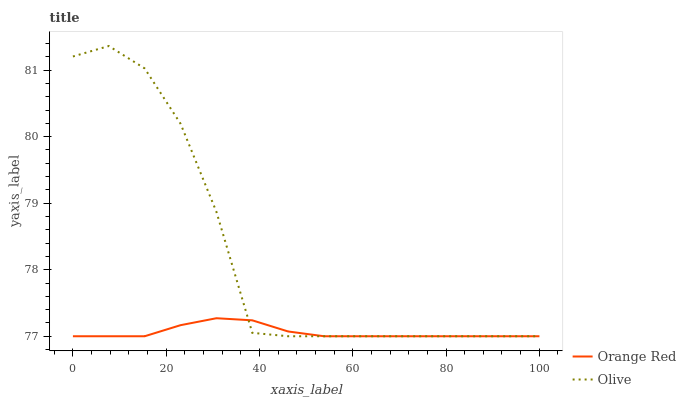Does Orange Red have the minimum area under the curve?
Answer yes or no. Yes. Does Olive have the maximum area under the curve?
Answer yes or no. Yes. Does Orange Red have the maximum area under the curve?
Answer yes or no. No. Is Orange Red the smoothest?
Answer yes or no. Yes. Is Olive the roughest?
Answer yes or no. Yes. Is Orange Red the roughest?
Answer yes or no. No. Does Olive have the lowest value?
Answer yes or no. Yes. Does Olive have the highest value?
Answer yes or no. Yes. Does Orange Red have the highest value?
Answer yes or no. No. Does Olive intersect Orange Red?
Answer yes or no. Yes. Is Olive less than Orange Red?
Answer yes or no. No. Is Olive greater than Orange Red?
Answer yes or no. No. 